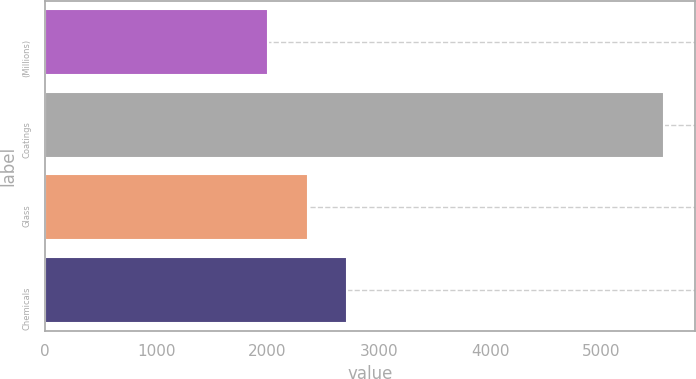<chart> <loc_0><loc_0><loc_500><loc_500><bar_chart><fcel>(Millions)<fcel>Coatings<fcel>Glass<fcel>Chemicals<nl><fcel>2005<fcel>5566<fcel>2361.1<fcel>2717.2<nl></chart> 